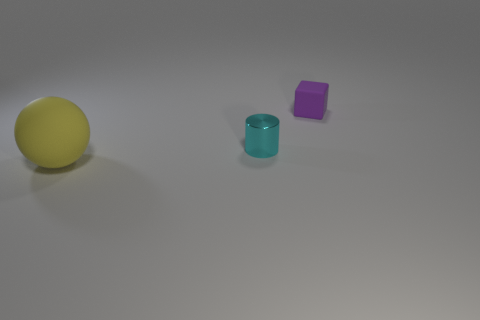Can you tell me the colors of the objects in the image? Certainly! In the image, there are three objects of distinct colors. From left to right, we have a yellow ball, a cyan cylinder, and a purple cube. 